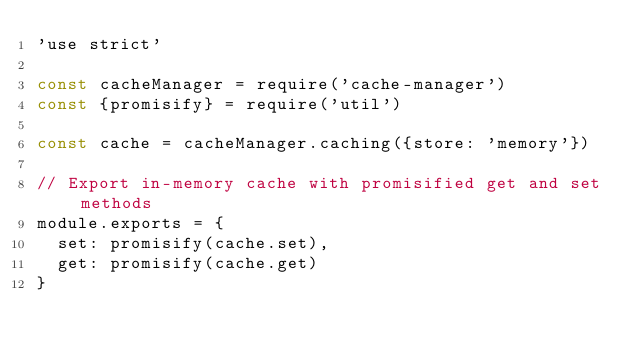Convert code to text. <code><loc_0><loc_0><loc_500><loc_500><_JavaScript_>'use strict'

const cacheManager = require('cache-manager')
const {promisify} = require('util')

const cache = cacheManager.caching({store: 'memory'})

// Export in-memory cache with promisified get and set methods
module.exports = {
  set: promisify(cache.set),
  get: promisify(cache.get)
}
</code> 